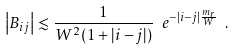Convert formula to latex. <formula><loc_0><loc_0><loc_500><loc_500>\left | B _ { i j } \right | \lesssim \frac { 1 } { W ^ { 2 } ( 1 + | i - j | ) } \ e ^ { - | i - j | \frac { m _ { r } } { W } } \ .</formula> 